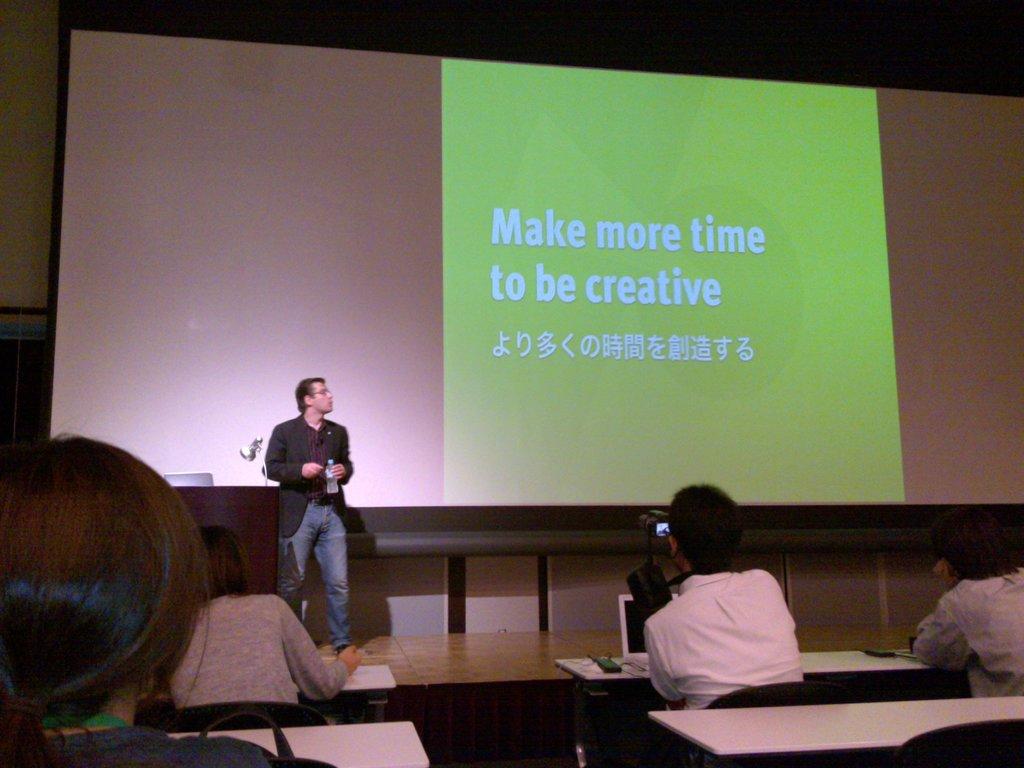What should you make more time for?
Your response must be concise. To be creative. What should you make more of to be creative?
Ensure brevity in your answer.  Time. 